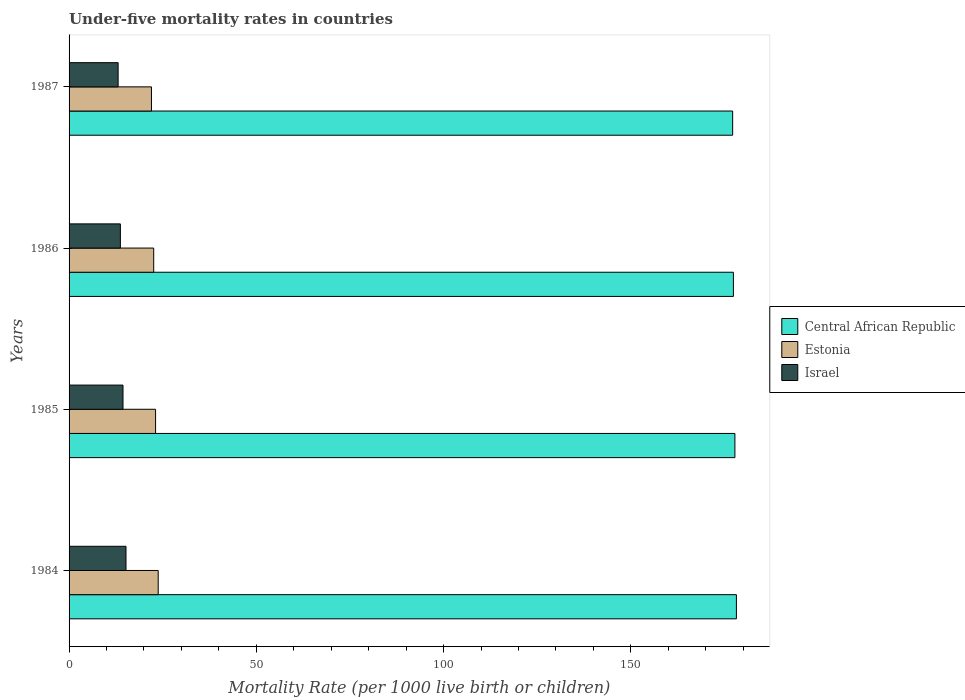How many groups of bars are there?
Provide a short and direct response. 4. Are the number of bars per tick equal to the number of legend labels?
Make the answer very short. Yes. Are the number of bars on each tick of the Y-axis equal?
Your answer should be compact. Yes. How many bars are there on the 4th tick from the top?
Provide a succinct answer. 3. How many bars are there on the 3rd tick from the bottom?
Your answer should be compact. 3. What is the label of the 4th group of bars from the top?
Your response must be concise. 1984. What is the under-five mortality rate in Estonia in 1986?
Your answer should be compact. 22.6. Across all years, what is the maximum under-five mortality rate in Central African Republic?
Offer a very short reply. 178.2. In which year was the under-five mortality rate in Estonia maximum?
Offer a very short reply. 1984. What is the total under-five mortality rate in Estonia in the graph?
Your response must be concise. 91.5. What is the difference between the under-five mortality rate in Estonia in 1985 and that in 1987?
Provide a short and direct response. 1.1. What is the difference between the under-five mortality rate in Central African Republic in 1987 and the under-five mortality rate in Israel in 1985?
Provide a short and direct response. 162.8. What is the average under-five mortality rate in Central African Republic per year?
Your answer should be compact. 177.65. In the year 1987, what is the difference between the under-five mortality rate in Israel and under-five mortality rate in Central African Republic?
Offer a very short reply. -164.1. What is the ratio of the under-five mortality rate in Central African Republic in 1986 to that in 1987?
Give a very brief answer. 1. Is the under-five mortality rate in Central African Republic in 1984 less than that in 1986?
Ensure brevity in your answer.  No. Is the difference between the under-five mortality rate in Israel in 1986 and 1987 greater than the difference between the under-five mortality rate in Central African Republic in 1986 and 1987?
Provide a short and direct response. Yes. What is the difference between the highest and the second highest under-five mortality rate in Estonia?
Keep it short and to the point. 0.7. What is the difference between the highest and the lowest under-five mortality rate in Estonia?
Give a very brief answer. 1.8. Is the sum of the under-five mortality rate in Central African Republic in 1984 and 1985 greater than the maximum under-five mortality rate in Israel across all years?
Offer a very short reply. Yes. What does the 2nd bar from the top in 1986 represents?
Keep it short and to the point. Estonia. Are all the bars in the graph horizontal?
Your answer should be compact. Yes. How many years are there in the graph?
Give a very brief answer. 4. What is the difference between two consecutive major ticks on the X-axis?
Provide a succinct answer. 50. Are the values on the major ticks of X-axis written in scientific E-notation?
Your answer should be compact. No. Does the graph contain any zero values?
Provide a succinct answer. No. Does the graph contain grids?
Your response must be concise. No. Where does the legend appear in the graph?
Give a very brief answer. Center right. How many legend labels are there?
Make the answer very short. 3. How are the legend labels stacked?
Give a very brief answer. Vertical. What is the title of the graph?
Offer a terse response. Under-five mortality rates in countries. What is the label or title of the X-axis?
Give a very brief answer. Mortality Rate (per 1000 live birth or children). What is the label or title of the Y-axis?
Your answer should be compact. Years. What is the Mortality Rate (per 1000 live birth or children) in Central African Republic in 1984?
Your response must be concise. 178.2. What is the Mortality Rate (per 1000 live birth or children) of Estonia in 1984?
Your response must be concise. 23.8. What is the Mortality Rate (per 1000 live birth or children) of Israel in 1984?
Your response must be concise. 15.2. What is the Mortality Rate (per 1000 live birth or children) in Central African Republic in 1985?
Keep it short and to the point. 177.8. What is the Mortality Rate (per 1000 live birth or children) in Estonia in 1985?
Offer a very short reply. 23.1. What is the Mortality Rate (per 1000 live birth or children) of Central African Republic in 1986?
Provide a short and direct response. 177.4. What is the Mortality Rate (per 1000 live birth or children) in Estonia in 1986?
Your answer should be compact. 22.6. What is the Mortality Rate (per 1000 live birth or children) of Israel in 1986?
Your response must be concise. 13.7. What is the Mortality Rate (per 1000 live birth or children) of Central African Republic in 1987?
Provide a short and direct response. 177.2. Across all years, what is the maximum Mortality Rate (per 1000 live birth or children) in Central African Republic?
Your answer should be very brief. 178.2. Across all years, what is the maximum Mortality Rate (per 1000 live birth or children) of Estonia?
Offer a terse response. 23.8. Across all years, what is the maximum Mortality Rate (per 1000 live birth or children) of Israel?
Give a very brief answer. 15.2. Across all years, what is the minimum Mortality Rate (per 1000 live birth or children) in Central African Republic?
Offer a terse response. 177.2. What is the total Mortality Rate (per 1000 live birth or children) in Central African Republic in the graph?
Provide a succinct answer. 710.6. What is the total Mortality Rate (per 1000 live birth or children) in Estonia in the graph?
Offer a terse response. 91.5. What is the total Mortality Rate (per 1000 live birth or children) in Israel in the graph?
Your answer should be very brief. 56.4. What is the difference between the Mortality Rate (per 1000 live birth or children) of Estonia in 1984 and that in 1985?
Give a very brief answer. 0.7. What is the difference between the Mortality Rate (per 1000 live birth or children) of Central African Republic in 1984 and that in 1987?
Ensure brevity in your answer.  1. What is the difference between the Mortality Rate (per 1000 live birth or children) in Estonia in 1984 and that in 1987?
Offer a terse response. 1.8. What is the difference between the Mortality Rate (per 1000 live birth or children) of Central African Republic in 1985 and that in 1986?
Offer a very short reply. 0.4. What is the difference between the Mortality Rate (per 1000 live birth or children) in Estonia in 1985 and that in 1986?
Give a very brief answer. 0.5. What is the difference between the Mortality Rate (per 1000 live birth or children) of Israel in 1985 and that in 1986?
Make the answer very short. 0.7. What is the difference between the Mortality Rate (per 1000 live birth or children) of Estonia in 1985 and that in 1987?
Provide a short and direct response. 1.1. What is the difference between the Mortality Rate (per 1000 live birth or children) in Central African Republic in 1986 and that in 1987?
Provide a succinct answer. 0.2. What is the difference between the Mortality Rate (per 1000 live birth or children) of Israel in 1986 and that in 1987?
Keep it short and to the point. 0.6. What is the difference between the Mortality Rate (per 1000 live birth or children) in Central African Republic in 1984 and the Mortality Rate (per 1000 live birth or children) in Estonia in 1985?
Your answer should be compact. 155.1. What is the difference between the Mortality Rate (per 1000 live birth or children) in Central African Republic in 1984 and the Mortality Rate (per 1000 live birth or children) in Israel in 1985?
Your answer should be compact. 163.8. What is the difference between the Mortality Rate (per 1000 live birth or children) in Central African Republic in 1984 and the Mortality Rate (per 1000 live birth or children) in Estonia in 1986?
Your answer should be compact. 155.6. What is the difference between the Mortality Rate (per 1000 live birth or children) in Central African Republic in 1984 and the Mortality Rate (per 1000 live birth or children) in Israel in 1986?
Give a very brief answer. 164.5. What is the difference between the Mortality Rate (per 1000 live birth or children) of Central African Republic in 1984 and the Mortality Rate (per 1000 live birth or children) of Estonia in 1987?
Ensure brevity in your answer.  156.2. What is the difference between the Mortality Rate (per 1000 live birth or children) in Central African Republic in 1984 and the Mortality Rate (per 1000 live birth or children) in Israel in 1987?
Your answer should be compact. 165.1. What is the difference between the Mortality Rate (per 1000 live birth or children) of Central African Republic in 1985 and the Mortality Rate (per 1000 live birth or children) of Estonia in 1986?
Offer a terse response. 155.2. What is the difference between the Mortality Rate (per 1000 live birth or children) in Central African Republic in 1985 and the Mortality Rate (per 1000 live birth or children) in Israel in 1986?
Your answer should be very brief. 164.1. What is the difference between the Mortality Rate (per 1000 live birth or children) in Estonia in 1985 and the Mortality Rate (per 1000 live birth or children) in Israel in 1986?
Offer a terse response. 9.4. What is the difference between the Mortality Rate (per 1000 live birth or children) of Central African Republic in 1985 and the Mortality Rate (per 1000 live birth or children) of Estonia in 1987?
Your answer should be very brief. 155.8. What is the difference between the Mortality Rate (per 1000 live birth or children) in Central African Republic in 1985 and the Mortality Rate (per 1000 live birth or children) in Israel in 1987?
Ensure brevity in your answer.  164.7. What is the difference between the Mortality Rate (per 1000 live birth or children) of Central African Republic in 1986 and the Mortality Rate (per 1000 live birth or children) of Estonia in 1987?
Offer a terse response. 155.4. What is the difference between the Mortality Rate (per 1000 live birth or children) of Central African Republic in 1986 and the Mortality Rate (per 1000 live birth or children) of Israel in 1987?
Ensure brevity in your answer.  164.3. What is the average Mortality Rate (per 1000 live birth or children) in Central African Republic per year?
Give a very brief answer. 177.65. What is the average Mortality Rate (per 1000 live birth or children) in Estonia per year?
Make the answer very short. 22.88. What is the average Mortality Rate (per 1000 live birth or children) of Israel per year?
Your response must be concise. 14.1. In the year 1984, what is the difference between the Mortality Rate (per 1000 live birth or children) of Central African Republic and Mortality Rate (per 1000 live birth or children) of Estonia?
Your answer should be very brief. 154.4. In the year 1984, what is the difference between the Mortality Rate (per 1000 live birth or children) in Central African Republic and Mortality Rate (per 1000 live birth or children) in Israel?
Your answer should be compact. 163. In the year 1985, what is the difference between the Mortality Rate (per 1000 live birth or children) of Central African Republic and Mortality Rate (per 1000 live birth or children) of Estonia?
Offer a terse response. 154.7. In the year 1985, what is the difference between the Mortality Rate (per 1000 live birth or children) of Central African Republic and Mortality Rate (per 1000 live birth or children) of Israel?
Offer a terse response. 163.4. In the year 1986, what is the difference between the Mortality Rate (per 1000 live birth or children) in Central African Republic and Mortality Rate (per 1000 live birth or children) in Estonia?
Keep it short and to the point. 154.8. In the year 1986, what is the difference between the Mortality Rate (per 1000 live birth or children) of Central African Republic and Mortality Rate (per 1000 live birth or children) of Israel?
Offer a terse response. 163.7. In the year 1987, what is the difference between the Mortality Rate (per 1000 live birth or children) of Central African Republic and Mortality Rate (per 1000 live birth or children) of Estonia?
Provide a short and direct response. 155.2. In the year 1987, what is the difference between the Mortality Rate (per 1000 live birth or children) of Central African Republic and Mortality Rate (per 1000 live birth or children) of Israel?
Give a very brief answer. 164.1. What is the ratio of the Mortality Rate (per 1000 live birth or children) of Estonia in 1984 to that in 1985?
Offer a terse response. 1.03. What is the ratio of the Mortality Rate (per 1000 live birth or children) in Israel in 1984 to that in 1985?
Offer a terse response. 1.06. What is the ratio of the Mortality Rate (per 1000 live birth or children) in Estonia in 1984 to that in 1986?
Offer a very short reply. 1.05. What is the ratio of the Mortality Rate (per 1000 live birth or children) of Israel in 1984 to that in 1986?
Offer a terse response. 1.11. What is the ratio of the Mortality Rate (per 1000 live birth or children) in Central African Republic in 1984 to that in 1987?
Keep it short and to the point. 1.01. What is the ratio of the Mortality Rate (per 1000 live birth or children) of Estonia in 1984 to that in 1987?
Your answer should be compact. 1.08. What is the ratio of the Mortality Rate (per 1000 live birth or children) of Israel in 1984 to that in 1987?
Provide a succinct answer. 1.16. What is the ratio of the Mortality Rate (per 1000 live birth or children) of Estonia in 1985 to that in 1986?
Your answer should be compact. 1.02. What is the ratio of the Mortality Rate (per 1000 live birth or children) of Israel in 1985 to that in 1986?
Provide a succinct answer. 1.05. What is the ratio of the Mortality Rate (per 1000 live birth or children) in Central African Republic in 1985 to that in 1987?
Give a very brief answer. 1. What is the ratio of the Mortality Rate (per 1000 live birth or children) in Estonia in 1985 to that in 1987?
Provide a short and direct response. 1.05. What is the ratio of the Mortality Rate (per 1000 live birth or children) of Israel in 1985 to that in 1987?
Your answer should be compact. 1.1. What is the ratio of the Mortality Rate (per 1000 live birth or children) in Estonia in 1986 to that in 1987?
Give a very brief answer. 1.03. What is the ratio of the Mortality Rate (per 1000 live birth or children) of Israel in 1986 to that in 1987?
Ensure brevity in your answer.  1.05. What is the difference between the highest and the second highest Mortality Rate (per 1000 live birth or children) in Central African Republic?
Give a very brief answer. 0.4. What is the difference between the highest and the second highest Mortality Rate (per 1000 live birth or children) in Estonia?
Make the answer very short. 0.7. What is the difference between the highest and the lowest Mortality Rate (per 1000 live birth or children) of Central African Republic?
Make the answer very short. 1. 